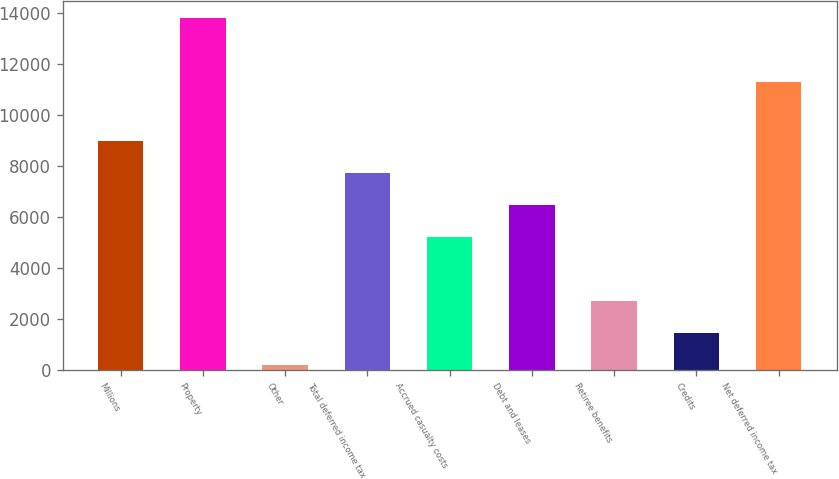<chart> <loc_0><loc_0><loc_500><loc_500><bar_chart><fcel>Millions<fcel>Property<fcel>Other<fcel>Total deferred income tax<fcel>Accrued casualty costs<fcel>Debt and leases<fcel>Retiree benefits<fcel>Credits<fcel>Net deferred income tax<nl><fcel>8984.7<fcel>13812.2<fcel>178<fcel>7726.6<fcel>5210.4<fcel>6468.5<fcel>2694.2<fcel>1436.1<fcel>11296<nl></chart> 